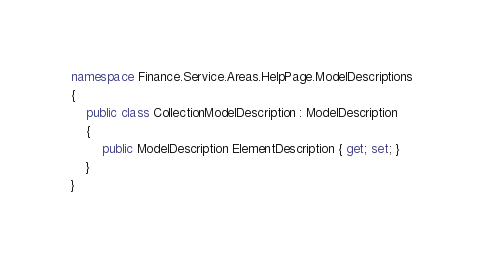Convert code to text. <code><loc_0><loc_0><loc_500><loc_500><_C#_>namespace Finance.Service.Areas.HelpPage.ModelDescriptions
{
    public class CollectionModelDescription : ModelDescription
    {
        public ModelDescription ElementDescription { get; set; }
    }
}</code> 